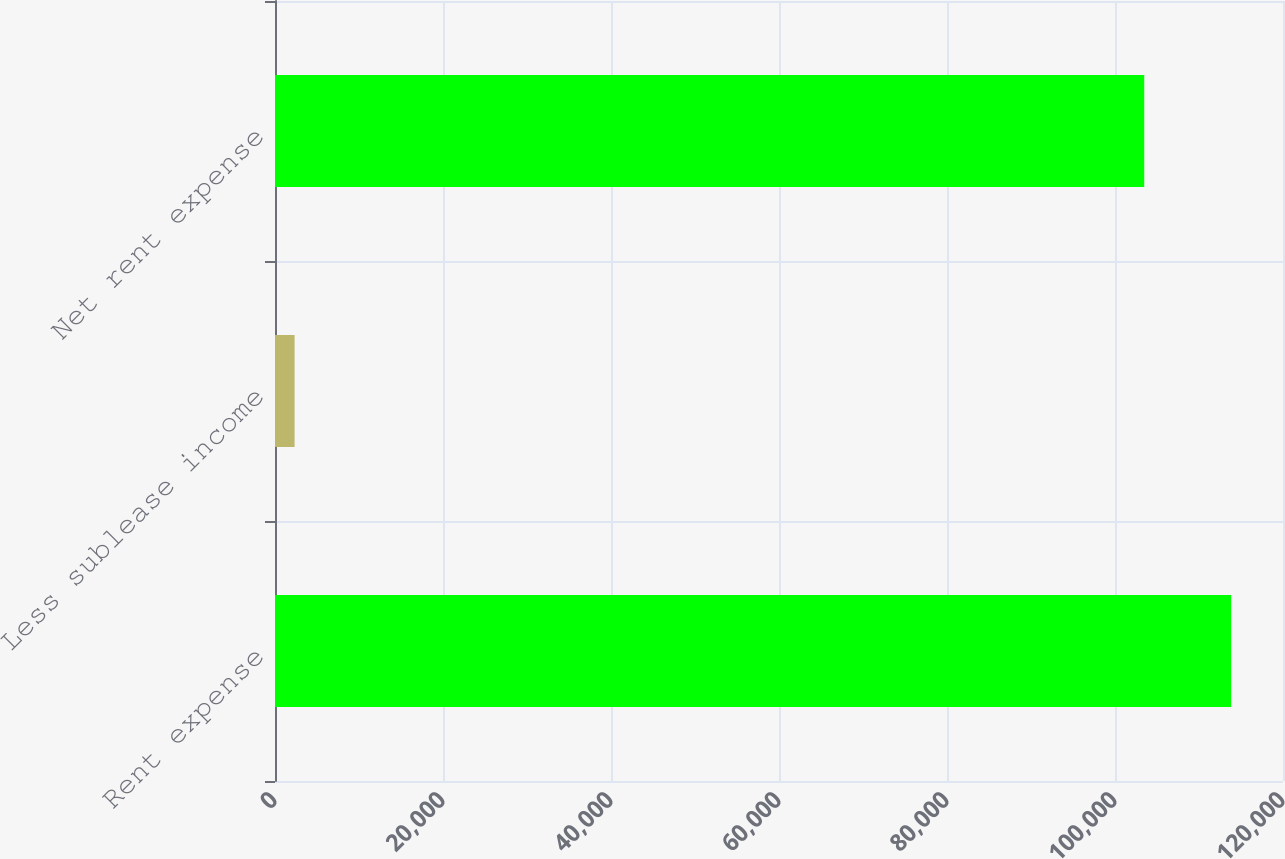Convert chart. <chart><loc_0><loc_0><loc_500><loc_500><bar_chart><fcel>Rent expense<fcel>Less sublease income<fcel>Net rent expense<nl><fcel>113827<fcel>2330<fcel>103479<nl></chart> 